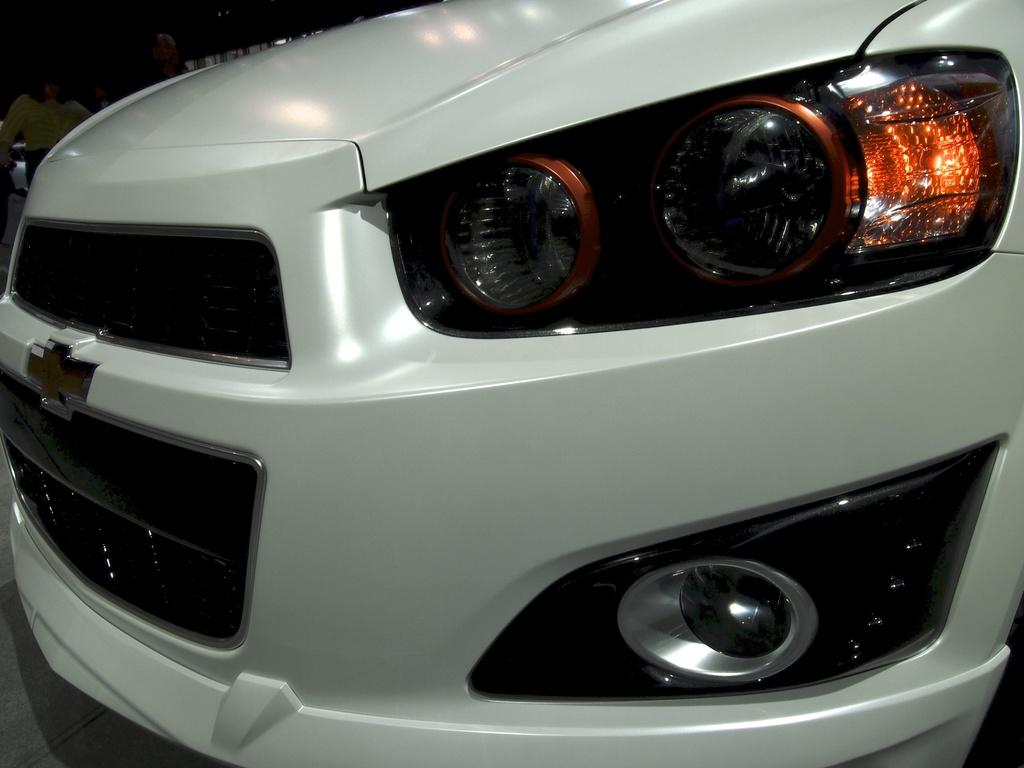What is the main subject of the image? The main subject of the image is the front part of a vehicle. Can you describe the people in the image? There are people standing in the top left corner of the image. What historical event is depicted in the image? There is no historical event depicted in the image; it features the front part of a vehicle and people standing nearby. Can you tell me how the eye of the vehicle functions in the image? There is no mention of an eye or any specific vehicle function in the image. 